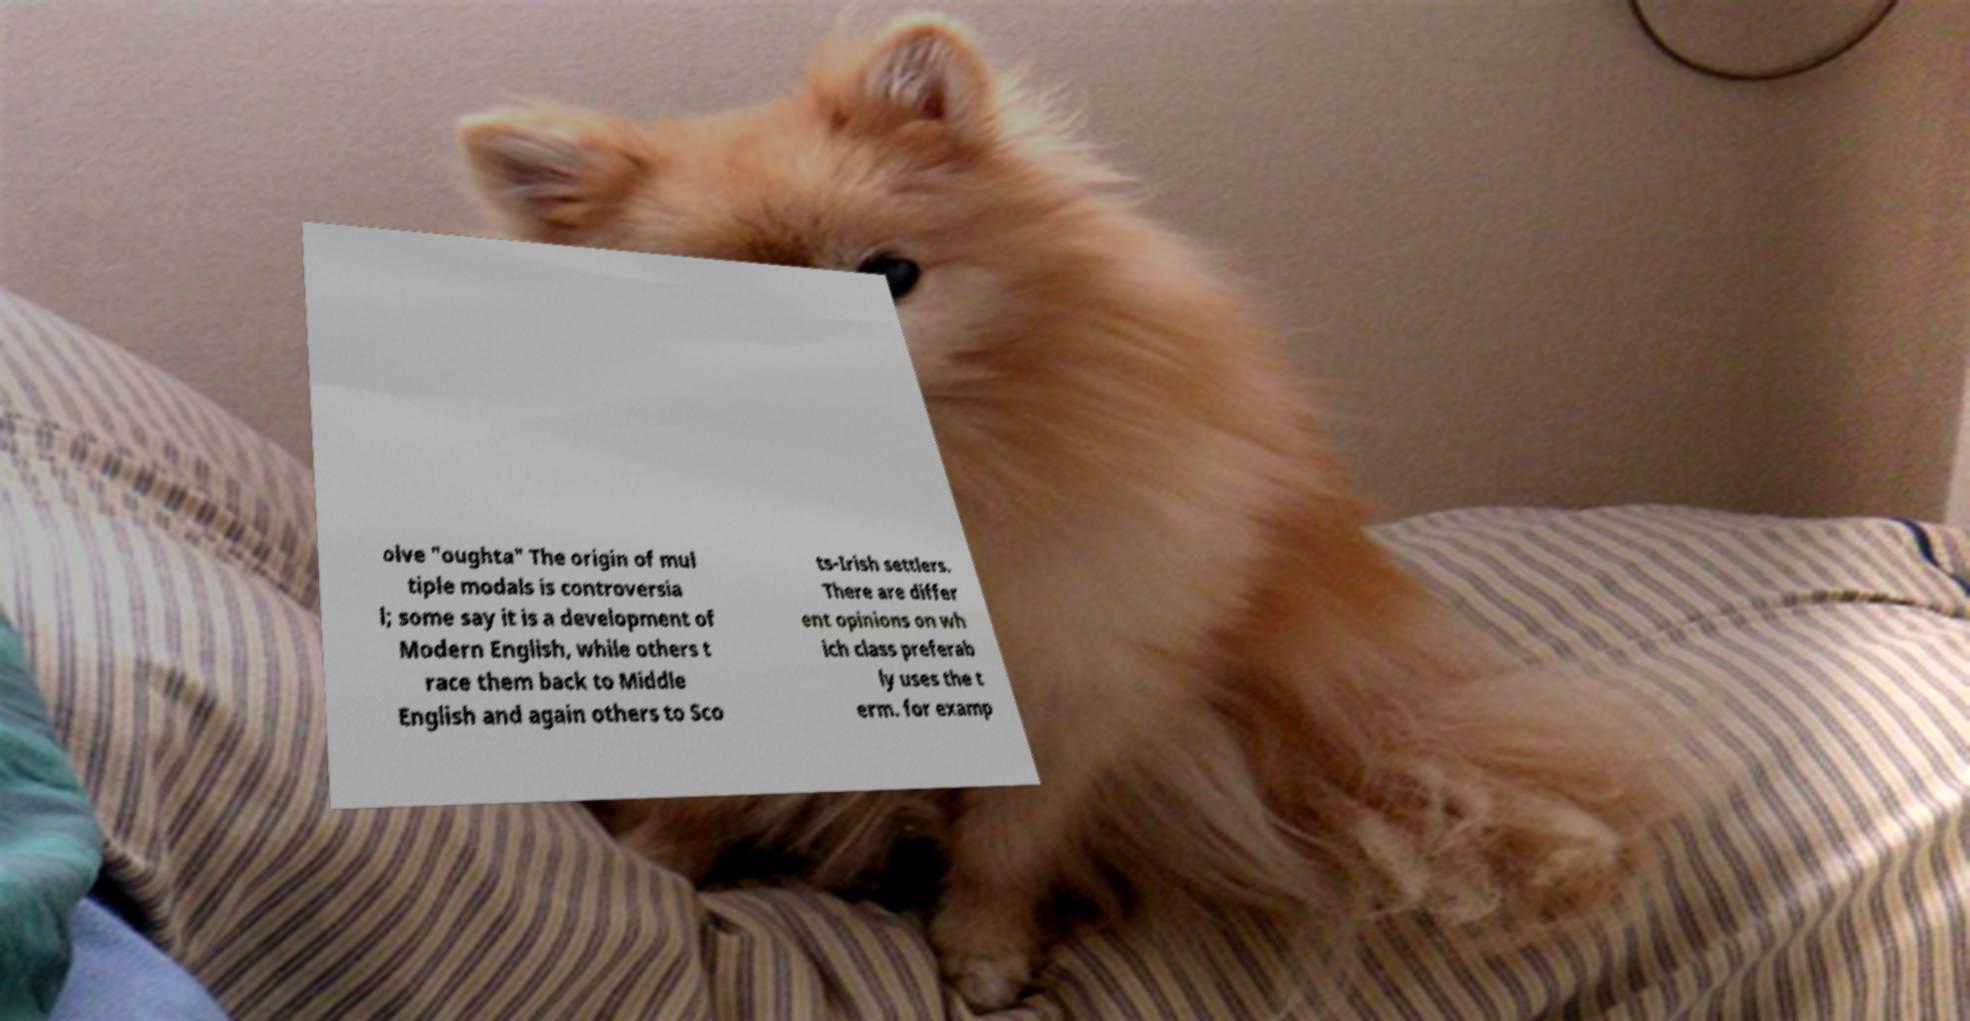Could you assist in decoding the text presented in this image and type it out clearly? olve "oughta" The origin of mul tiple modals is controversia l; some say it is a development of Modern English, while others t race them back to Middle English and again others to Sco ts-Irish settlers. There are differ ent opinions on wh ich class preferab ly uses the t erm. for examp 